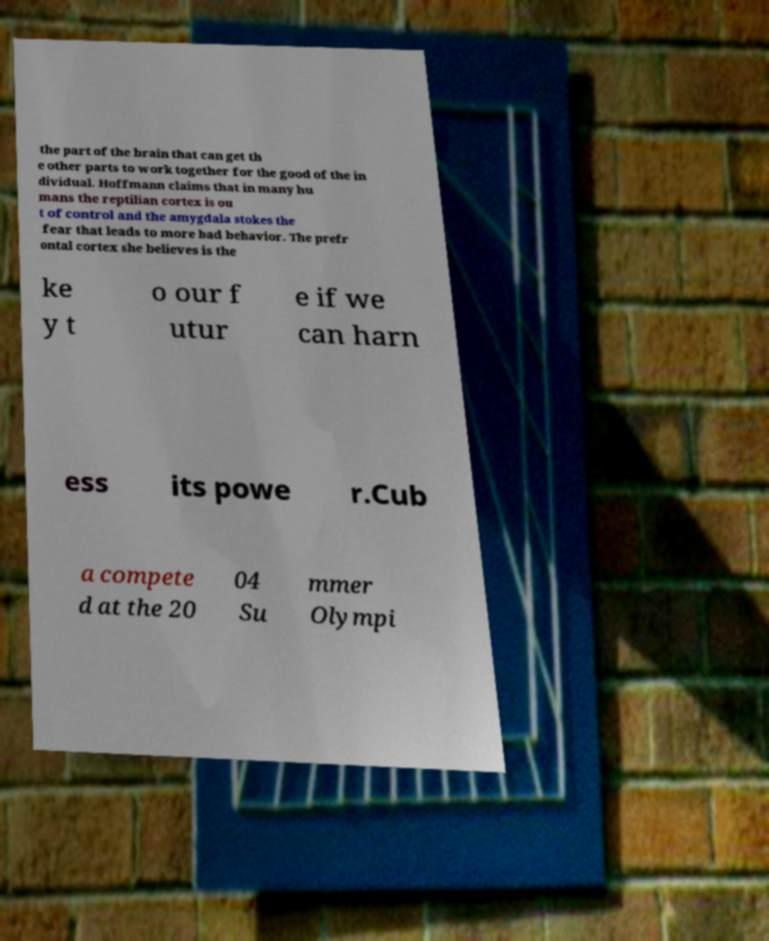Could you assist in decoding the text presented in this image and type it out clearly? the part of the brain that can get th e other parts to work together for the good of the in dividual. Hoffmann claims that in many hu mans the reptilian cortex is ou t of control and the amygdala stokes the fear that leads to more bad behavior. The prefr ontal cortex she believes is the ke y t o our f utur e if we can harn ess its powe r.Cub a compete d at the 20 04 Su mmer Olympi 